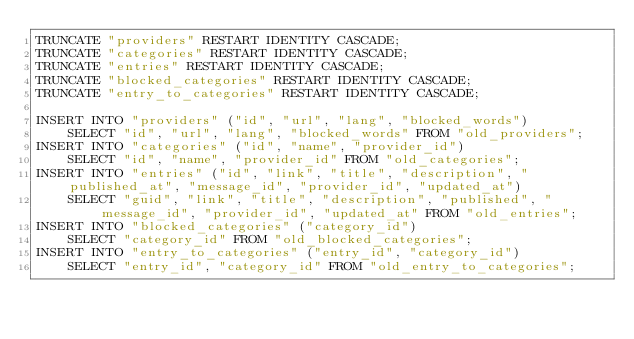Convert code to text. <code><loc_0><loc_0><loc_500><loc_500><_SQL_>TRUNCATE "providers" RESTART IDENTITY CASCADE;
TRUNCATE "categories" RESTART IDENTITY CASCADE;
TRUNCATE "entries" RESTART IDENTITY CASCADE;
TRUNCATE "blocked_categories" RESTART IDENTITY CASCADE;
TRUNCATE "entry_to_categories" RESTART IDENTITY CASCADE;

INSERT INTO "providers" ("id", "url", "lang", "blocked_words")
    SELECT "id", "url", "lang", "blocked_words" FROM "old_providers";
INSERT INTO "categories" ("id", "name", "provider_id")
    SELECT "id", "name", "provider_id" FROM "old_categories";
INSERT INTO "entries" ("id", "link", "title", "description", "published_at", "message_id", "provider_id", "updated_at")
    SELECT "guid", "link", "title", "description", "published", "message_id", "provider_id", "updated_at" FROM "old_entries";
INSERT INTO "blocked_categories" ("category_id")
    SELECT "category_id" FROM "old_blocked_categories";
INSERT INTO "entry_to_categories" ("entry_id", "category_id")
    SELECT "entry_id", "category_id" FROM "old_entry_to_categories";</code> 